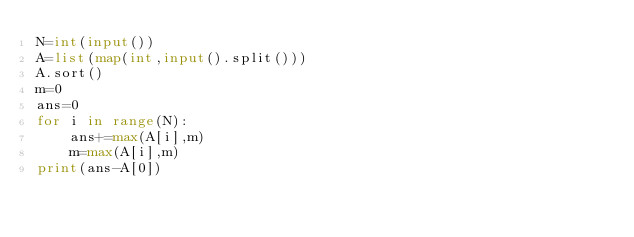<code> <loc_0><loc_0><loc_500><loc_500><_Python_>N=int(input())
A=list(map(int,input().split()))
A.sort()
m=0
ans=0
for i in range(N):
    ans+=max(A[i],m)
    m=max(A[i],m)
print(ans-A[0])</code> 